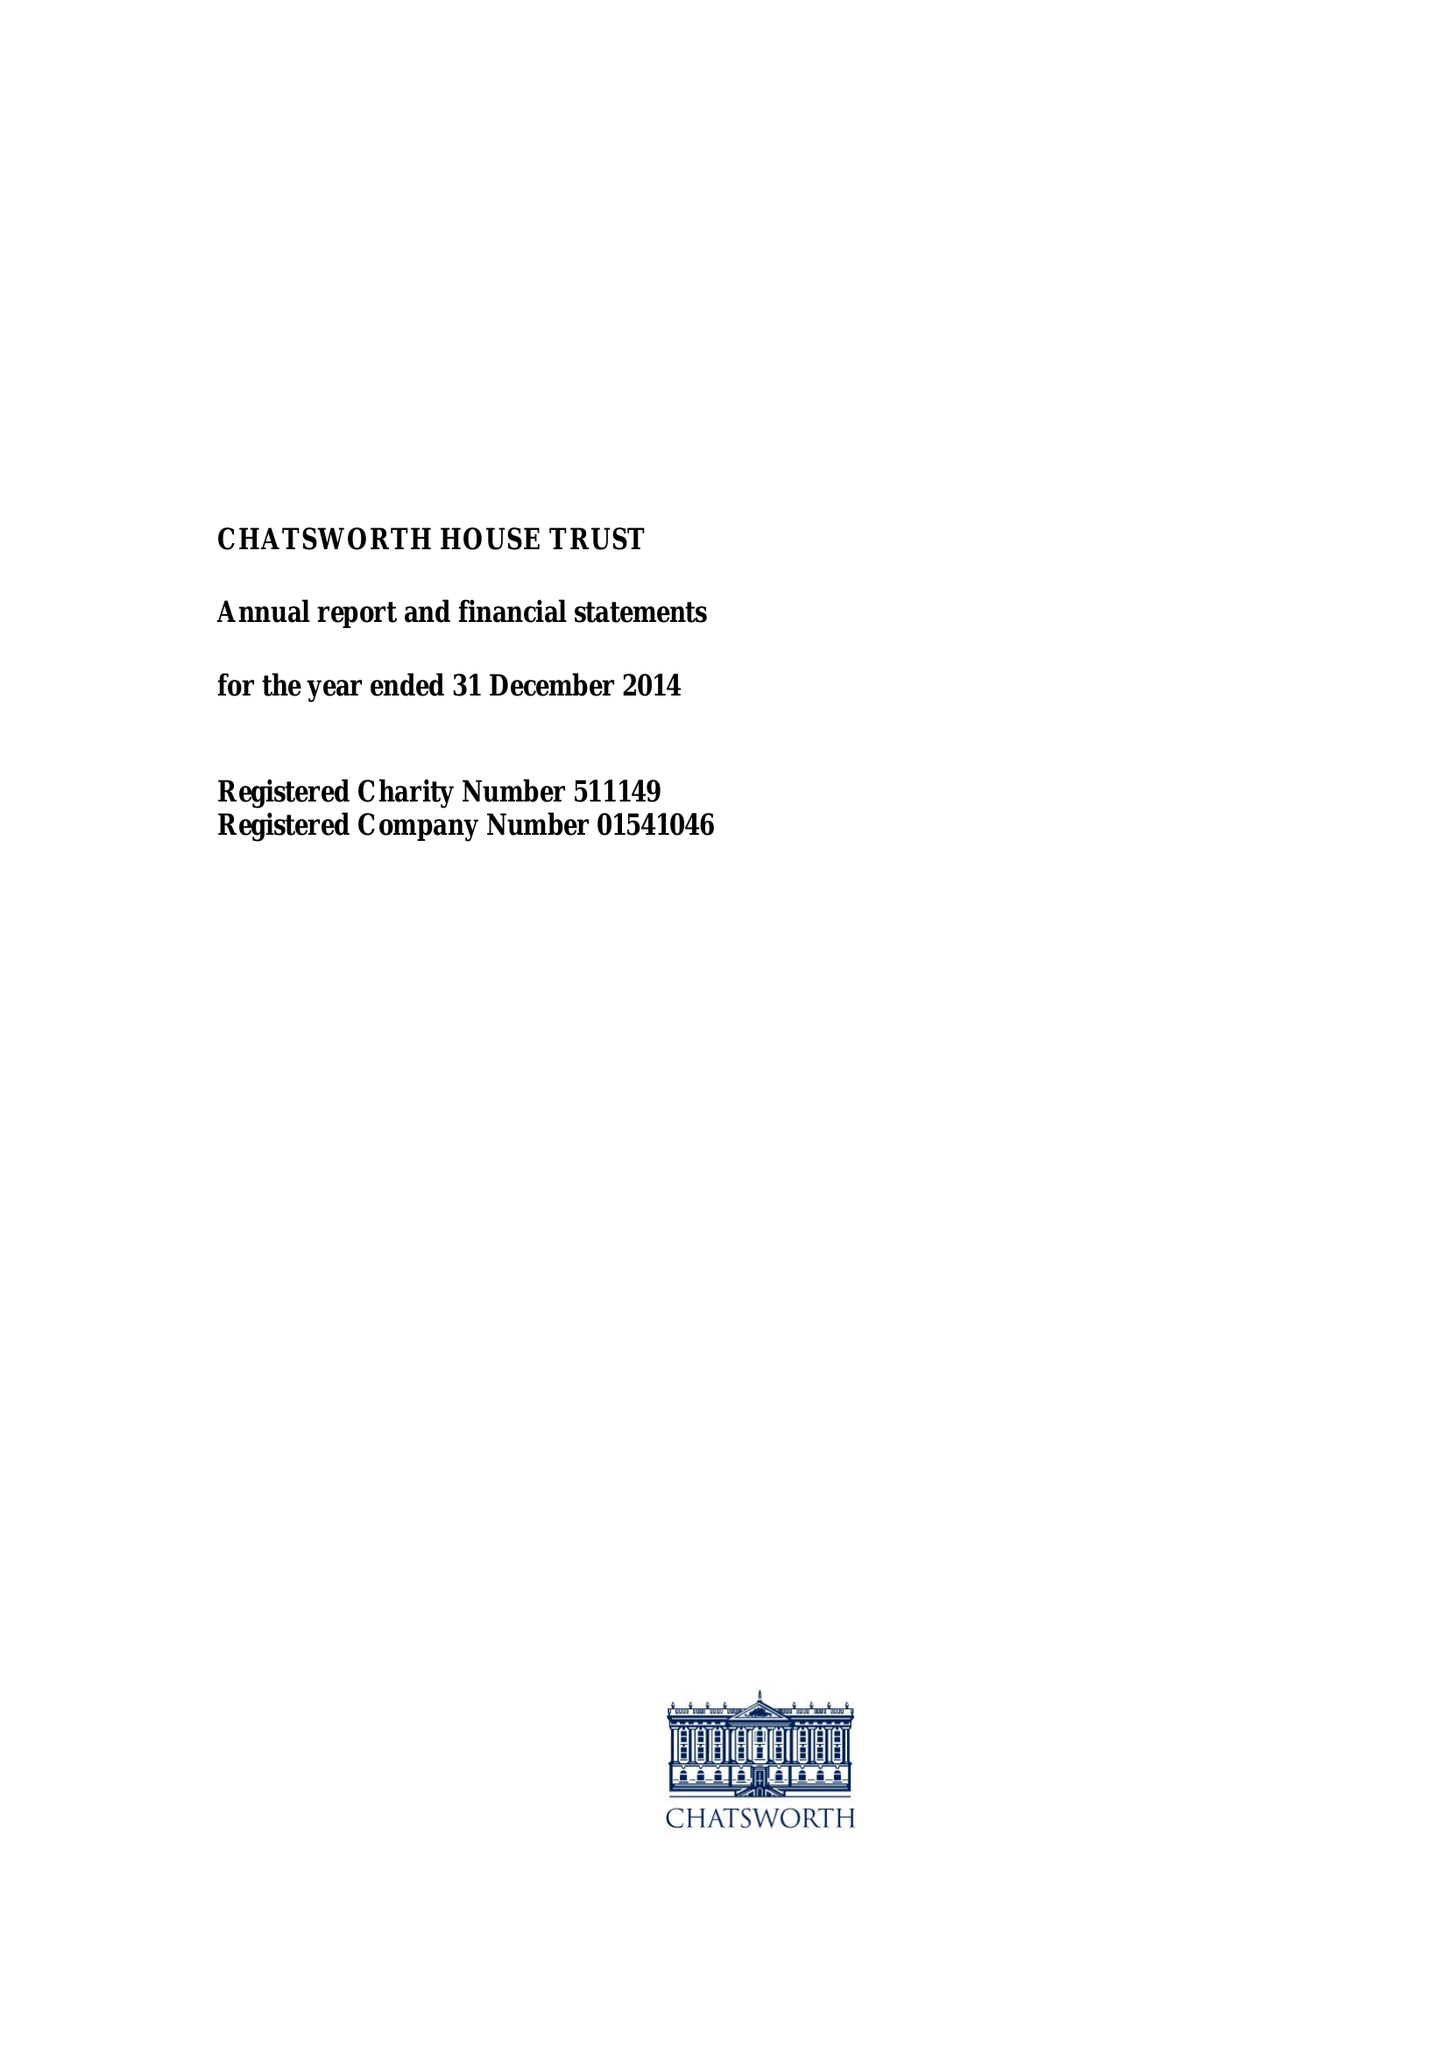What is the value for the income_annually_in_british_pounds?
Answer the question using a single word or phrase. 11735460.00 